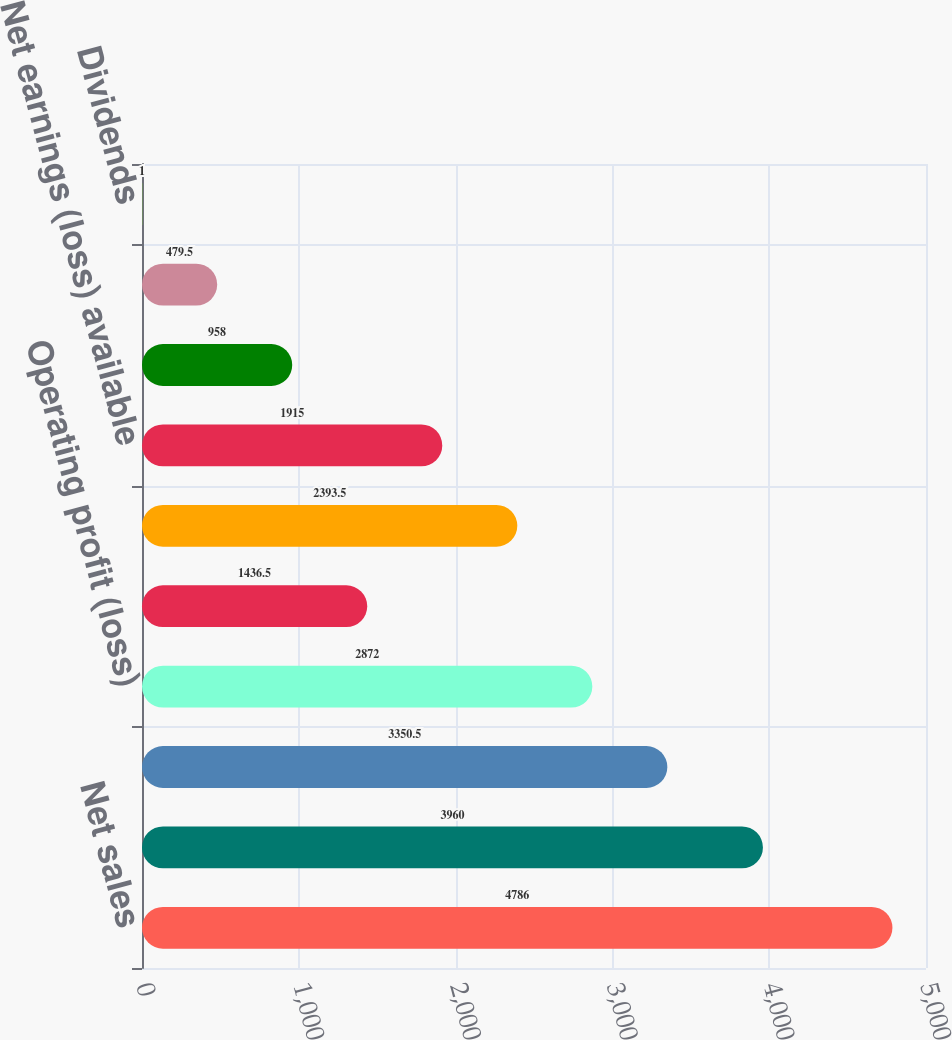Convert chart. <chart><loc_0><loc_0><loc_500><loc_500><bar_chart><fcel>Net sales<fcel>Cost of products sold<fcel>Gross margin<fcel>Operating profit (loss)<fcel>Interest and sundry (income)<fcel>Net earnings (loss)<fcel>Net earnings (loss) available<fcel>Basic net earnings (loss)<fcel>Diluted net earnings (loss)<fcel>Dividends<nl><fcel>4786<fcel>3960<fcel>3350.5<fcel>2872<fcel>1436.5<fcel>2393.5<fcel>1915<fcel>958<fcel>479.5<fcel>1<nl></chart> 